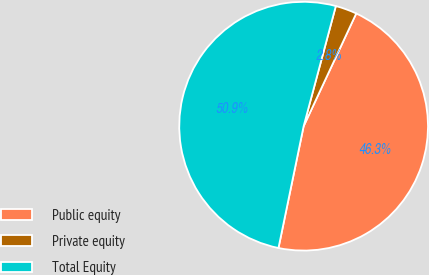<chart> <loc_0><loc_0><loc_500><loc_500><pie_chart><fcel>Public equity<fcel>Private equity<fcel>Total Equity<nl><fcel>46.3%<fcel>2.78%<fcel>50.93%<nl></chart> 